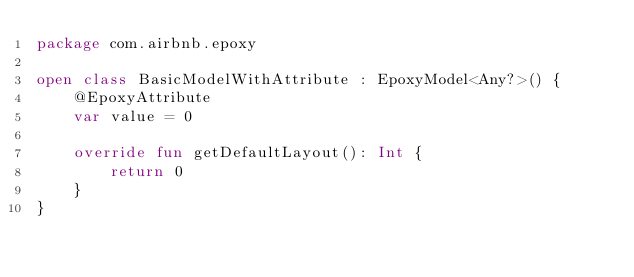Convert code to text. <code><loc_0><loc_0><loc_500><loc_500><_Kotlin_>package com.airbnb.epoxy

open class BasicModelWithAttribute : EpoxyModel<Any?>() {
    @EpoxyAttribute
    var value = 0

    override fun getDefaultLayout(): Int {
        return 0
    }
}
</code> 